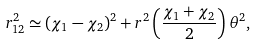Convert formula to latex. <formula><loc_0><loc_0><loc_500><loc_500>r ^ { 2 } _ { 1 2 } \simeq ( \chi _ { 1 } - \chi _ { 2 } ) ^ { 2 } + r ^ { 2 } \left ( \frac { \chi _ { 1 } + \chi _ { 2 } } { 2 } \right ) \theta ^ { 2 } ,</formula> 